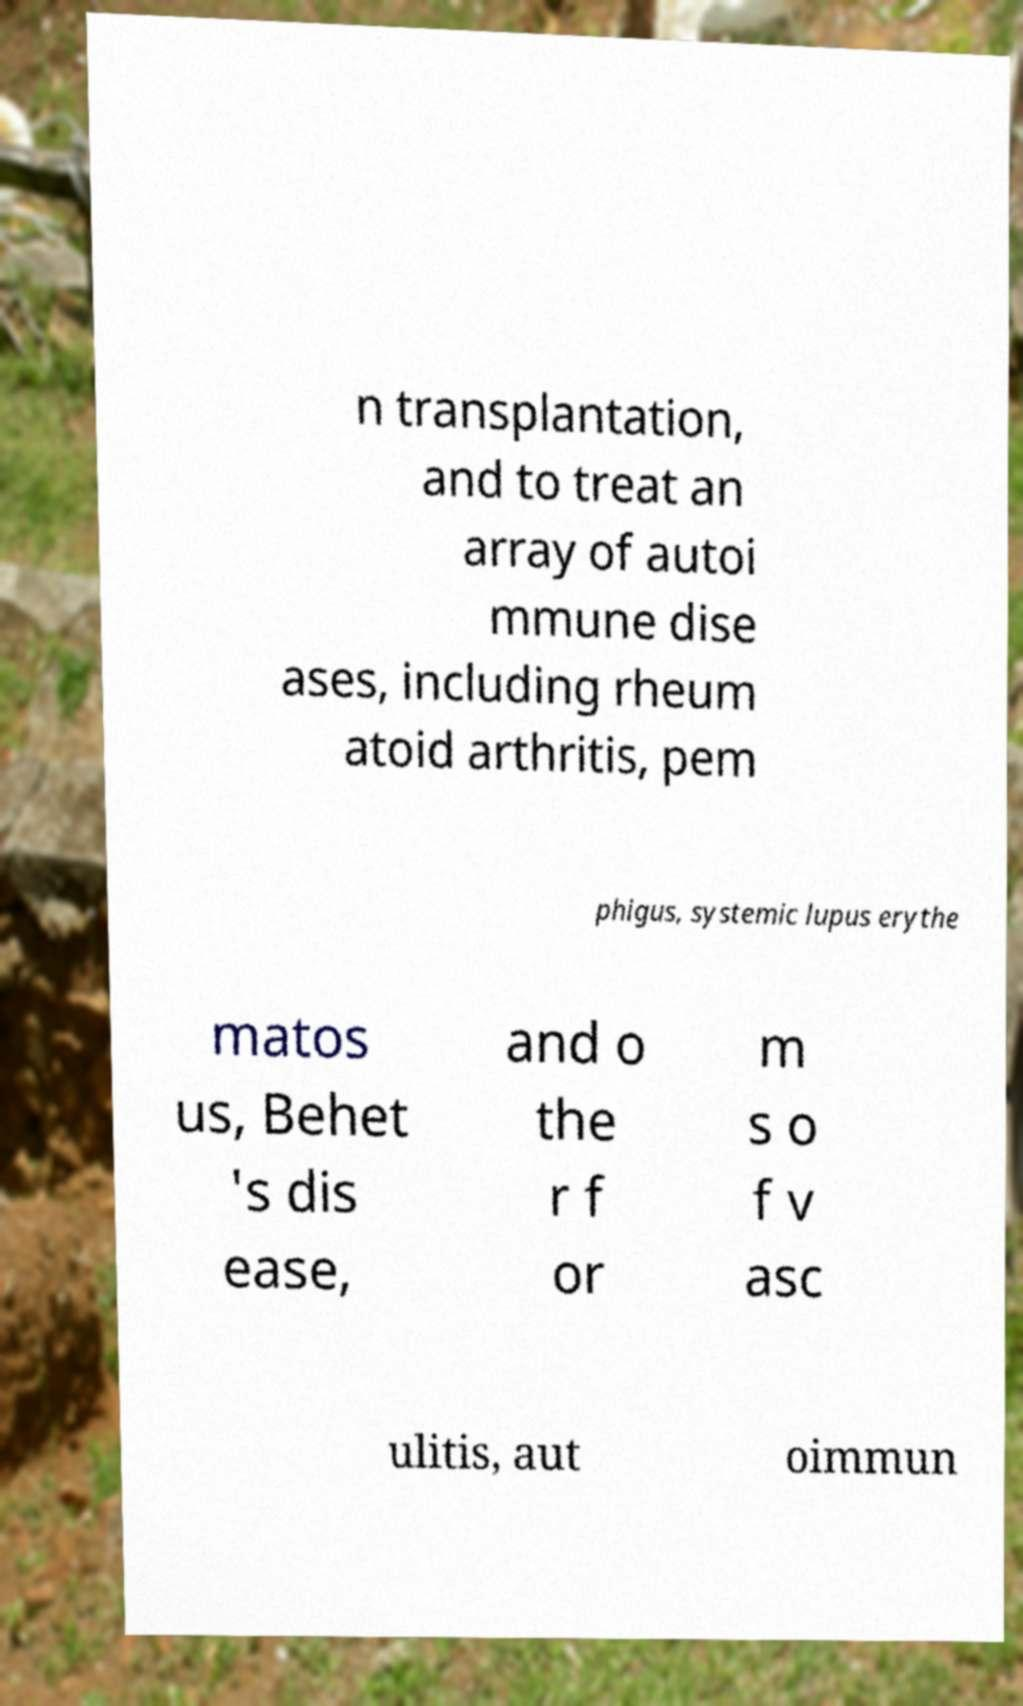I need the written content from this picture converted into text. Can you do that? n transplantation, and to treat an array of autoi mmune dise ases, including rheum atoid arthritis, pem phigus, systemic lupus erythe matos us, Behet 's dis ease, and o the r f or m s o f v asc ulitis, aut oimmun 